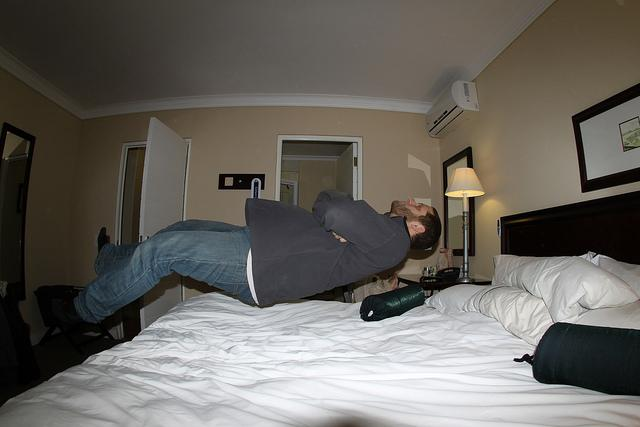The man here is posing to mimic what? Please explain your reasoning. levitation. He's pretending to be sleeping above the bed. 